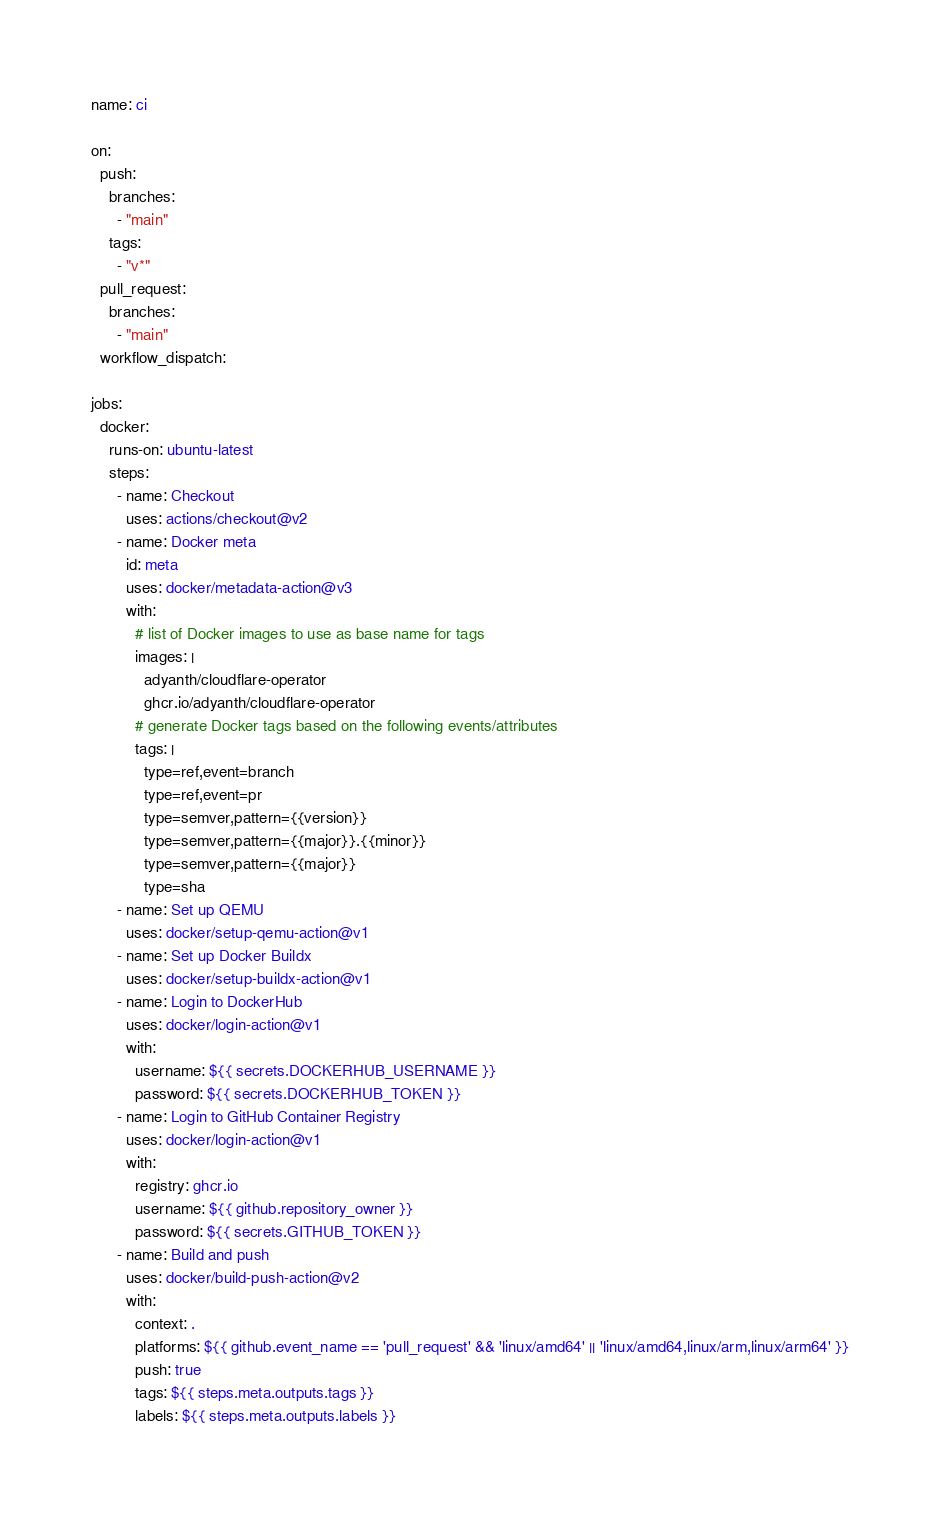<code> <loc_0><loc_0><loc_500><loc_500><_YAML_>name: ci

on:
  push:
    branches:
      - "main"
    tags:
      - "v*"
  pull_request:
    branches:
      - "main"
  workflow_dispatch:

jobs:
  docker:
    runs-on: ubuntu-latest
    steps:
      - name: Checkout
        uses: actions/checkout@v2
      - name: Docker meta
        id: meta
        uses: docker/metadata-action@v3
        with:
          # list of Docker images to use as base name for tags
          images: |
            adyanth/cloudflare-operator
            ghcr.io/adyanth/cloudflare-operator
          # generate Docker tags based on the following events/attributes
          tags: |
            type=ref,event=branch
            type=ref,event=pr
            type=semver,pattern={{version}}
            type=semver,pattern={{major}}.{{minor}}
            type=semver,pattern={{major}}
            type=sha
      - name: Set up QEMU
        uses: docker/setup-qemu-action@v1
      - name: Set up Docker Buildx
        uses: docker/setup-buildx-action@v1
      - name: Login to DockerHub
        uses: docker/login-action@v1
        with:
          username: ${{ secrets.DOCKERHUB_USERNAME }}
          password: ${{ secrets.DOCKERHUB_TOKEN }}
      - name: Login to GitHub Container Registry
        uses: docker/login-action@v1
        with:
          registry: ghcr.io
          username: ${{ github.repository_owner }}
          password: ${{ secrets.GITHUB_TOKEN }}
      - name: Build and push
        uses: docker/build-push-action@v2
        with:
          context: .
          platforms: ${{ github.event_name == 'pull_request' && 'linux/amd64' || 'linux/amd64,linux/arm,linux/arm64' }}
          push: true
          tags: ${{ steps.meta.outputs.tags }}
          labels: ${{ steps.meta.outputs.labels }}
</code> 